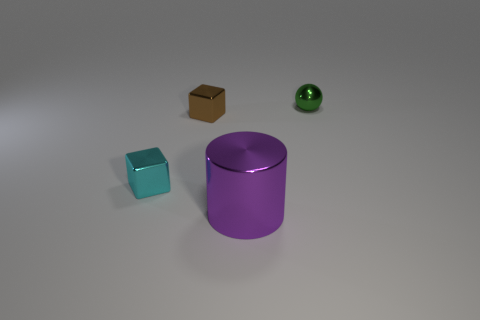There is a tiny cyan metal cube; how many purple metal objects are behind it? There are no purple metal objects positioned behind the tiny cyan metal cube. The only purple object in the scene is a large cylindrical shape, and it's located in front of the cyan cube when viewed from this perspective. 